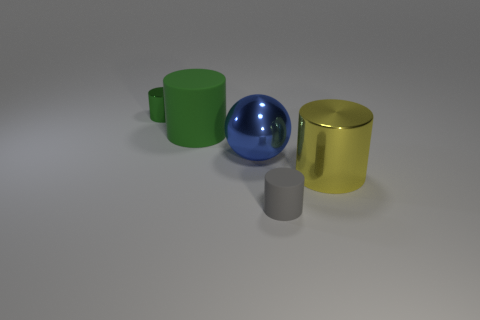Subtract all red cylinders. Subtract all gray spheres. How many cylinders are left? 4 Add 5 blue shiny blocks. How many objects exist? 10 Subtract all cylinders. How many objects are left? 1 Add 5 small gray metal objects. How many small gray metal objects exist? 5 Subtract 0 cyan blocks. How many objects are left? 5 Subtract all tiny green matte cylinders. Subtract all green metallic things. How many objects are left? 4 Add 4 large green rubber things. How many large green rubber things are left? 5 